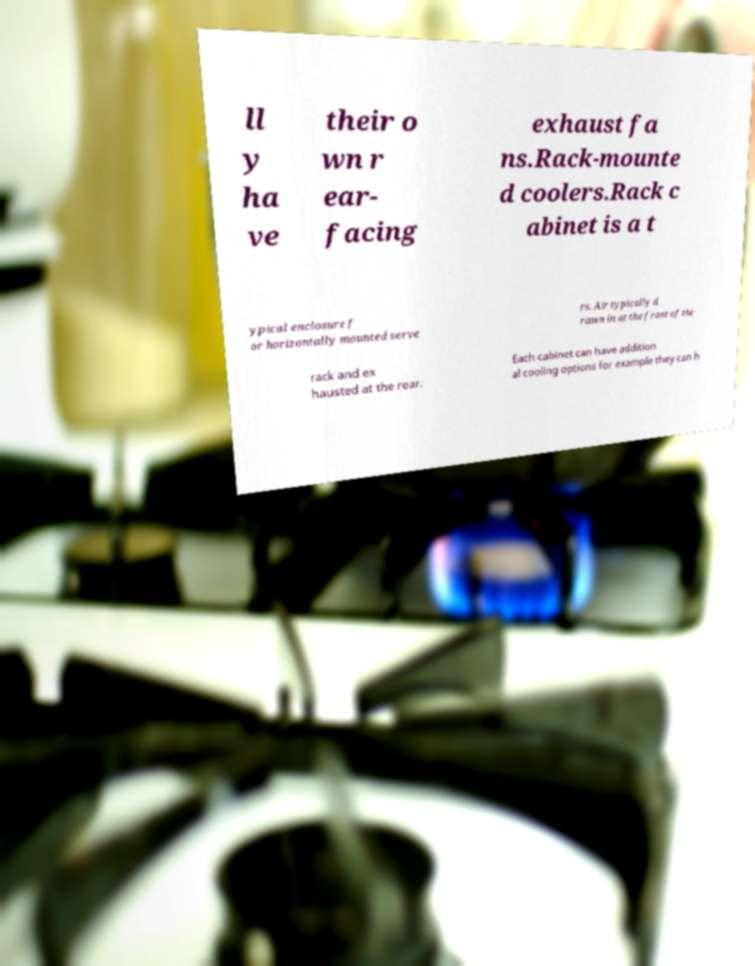There's text embedded in this image that I need extracted. Can you transcribe it verbatim? ll y ha ve their o wn r ear- facing exhaust fa ns.Rack-mounte d coolers.Rack c abinet is a t ypical enclosure f or horizontally mounted serve rs. Air typically d rawn in at the front of the rack and ex hausted at the rear. Each cabinet can have addition al cooling options for example they can h 